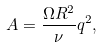Convert formula to latex. <formula><loc_0><loc_0><loc_500><loc_500>A = \frac { \Omega R ^ { 2 } } { \nu } q ^ { 2 } ,</formula> 